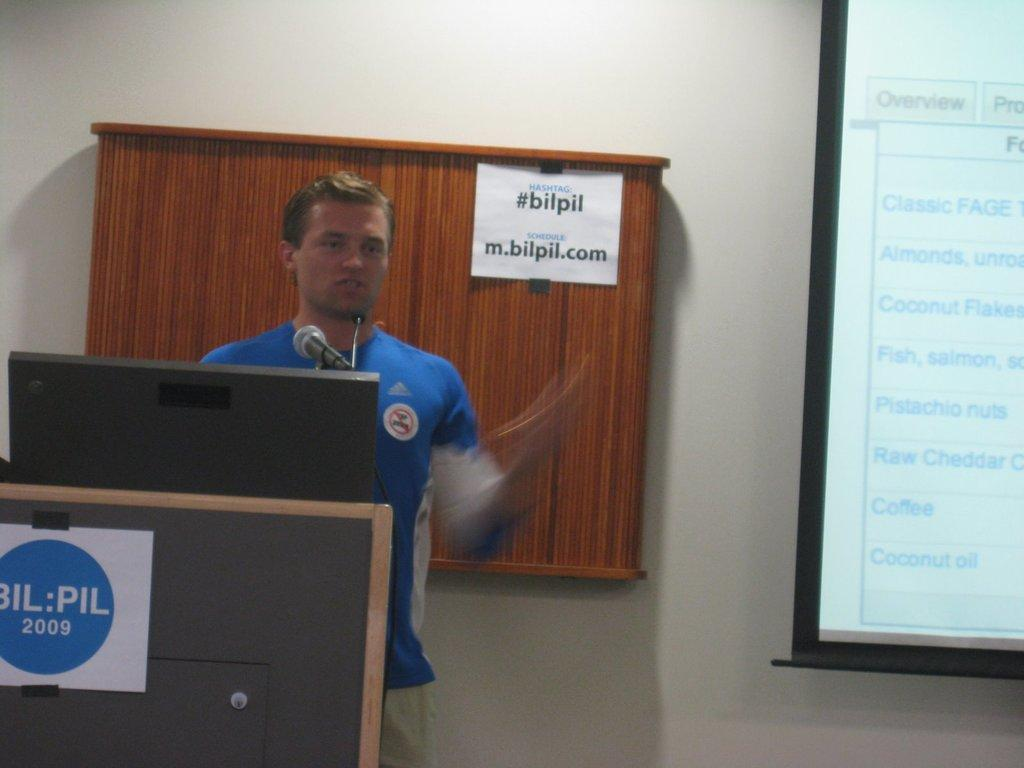What is the main subject of the image? There is a man standing in the image. What is the man wearing? The man is wearing a blue dress. What object can be seen near the man? There is a microphone (mic) in the image. What is the purpose of the projector screen in the image? The projector screen is likely used for displaying information or visuals. Can you describe the writing visible in the image? There is writing visible at a few places in the image, but the specific content cannot be determined from the facts provided. How many laborers are visible in the image? There are no laborers present in the image; it features a man standing in a blue dress with a microphone and a projector screen. What type of route is depicted on the projector screen? There is no route visible on the projector screen in the image. 